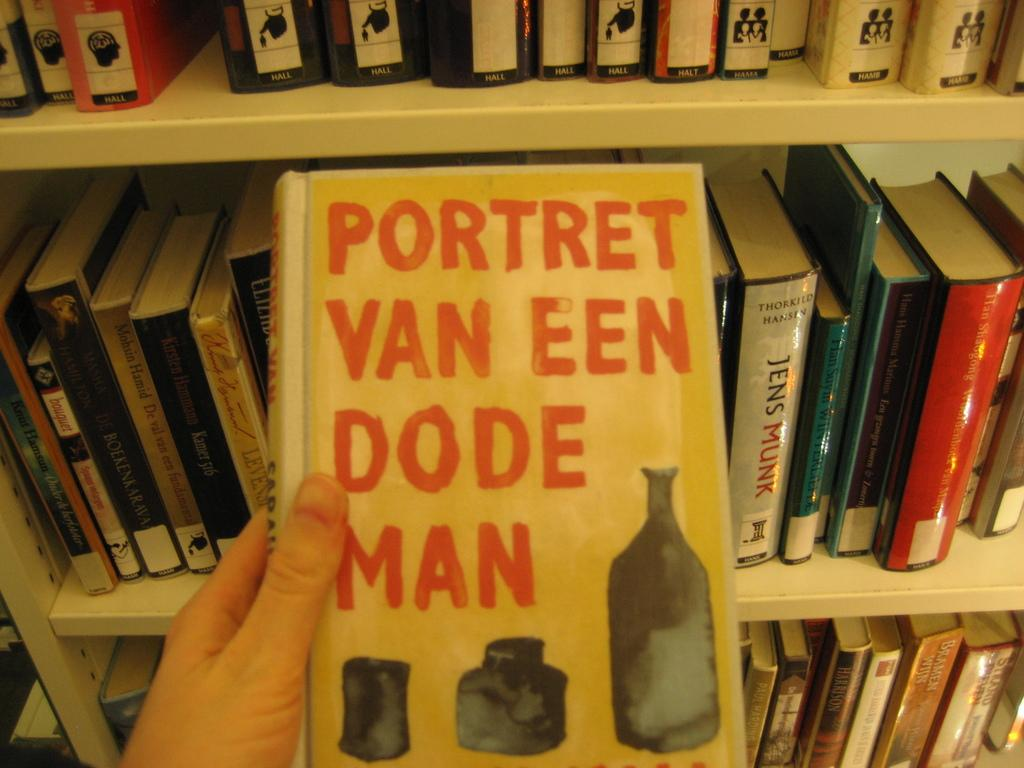<image>
Summarize the visual content of the image. Portret Van een dode man yellow chapter book 